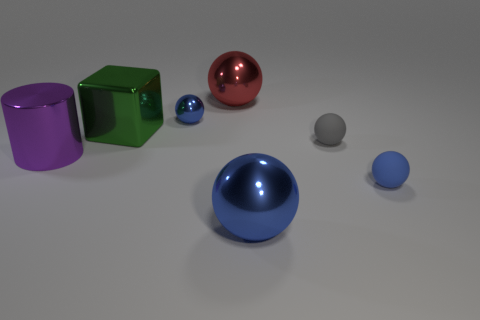There is a big metallic ball that is in front of the rubber thing that is on the right side of the small gray rubber sphere; what number of big balls are left of it?
Provide a succinct answer. 1. Is there any other thing that is the same size as the purple shiny cylinder?
Your answer should be compact. Yes. The tiny thing that is on the left side of the metallic sphere that is in front of the blue metallic sphere that is on the left side of the big blue metallic ball is what shape?
Ensure brevity in your answer.  Sphere. What number of other objects are there of the same color as the large metal cylinder?
Offer a very short reply. 0. What shape is the blue shiny thing on the left side of the large metal sphere in front of the big metal cylinder?
Ensure brevity in your answer.  Sphere. There is a large green object; how many big things are in front of it?
Ensure brevity in your answer.  2. Is there a red thing made of the same material as the cylinder?
Ensure brevity in your answer.  Yes. What is the material of the cube that is the same size as the purple metal object?
Your response must be concise. Metal. There is a shiny ball that is behind the big purple object and to the right of the small metallic thing; how big is it?
Offer a very short reply. Large. There is a big metal object that is in front of the tiny metal object and behind the gray matte object; what is its color?
Your answer should be compact. Green. 